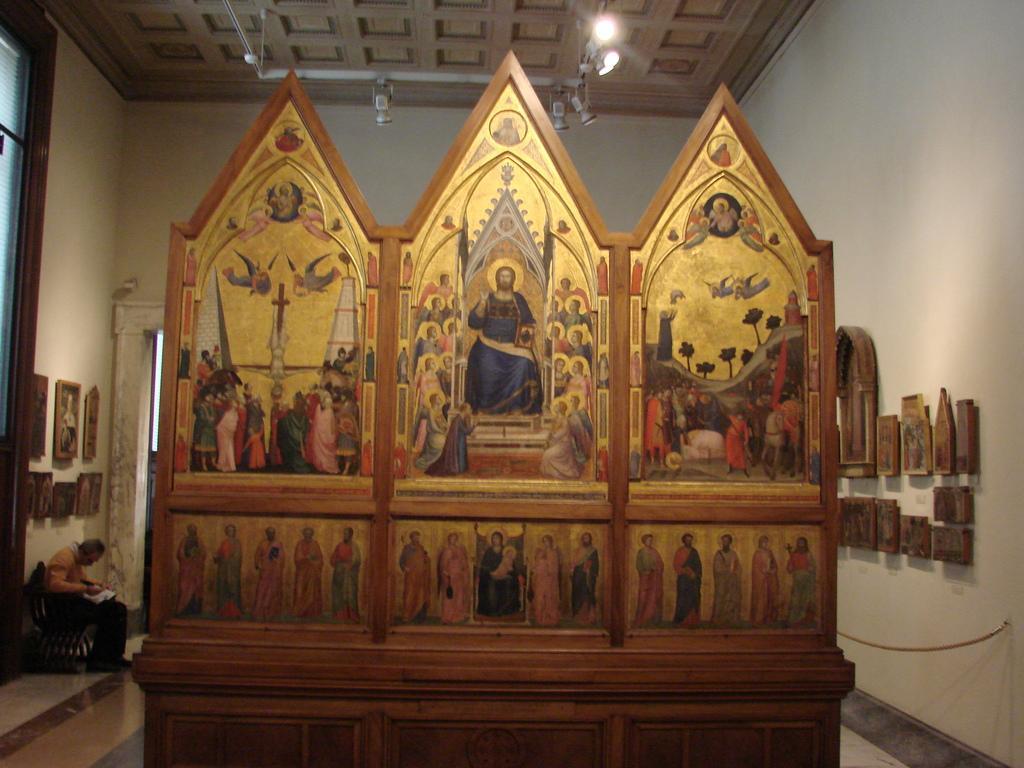In one or two sentences, can you explain what this image depicts? In this image, I can see the painting of people on a wooden object. At the bottom left side of the image, there is a person sitting on a bench. On the left and right side of the image, I can see the photo frames attached to the walls. At the top of the image, there are lights hanging to the ceiling. 